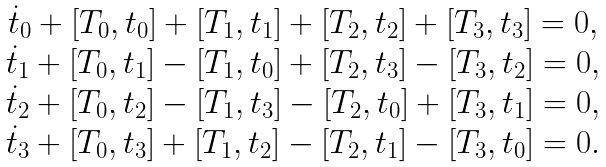Convert formula to latex. <formula><loc_0><loc_0><loc_500><loc_500>\begin{array} { c } { { \dot { t } _ { 0 } + [ T _ { 0 } , t _ { 0 } ] + [ T _ { 1 } , t _ { 1 } ] + [ T _ { 2 } , t _ { 2 } ] + [ T _ { 3 } , t _ { 3 } ] = 0 , } } \\ { { \dot { t } _ { 1 } + [ T _ { 0 } , t _ { 1 } ] - [ T _ { 1 } , t _ { 0 } ] + [ T _ { 2 } , t _ { 3 } ] - [ T _ { 3 } , t _ { 2 } ] = 0 , } } \\ { { \dot { t } _ { 2 } + [ T _ { 0 } , t _ { 2 } ] - [ T _ { 1 } , t _ { 3 } ] - [ T _ { 2 } , t _ { 0 } ] + [ T _ { 3 } , t _ { 1 } ] = 0 , } } \\ { { \dot { t } _ { 3 } + [ T _ { 0 } , t _ { 3 } ] + [ T _ { 1 } , t _ { 2 } ] - [ T _ { 2 } , t _ { 1 } ] - [ T _ { 3 } , t _ { 0 } ] = 0 . } } \end{array}</formula> 